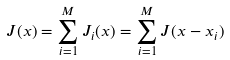Convert formula to latex. <formula><loc_0><loc_0><loc_500><loc_500>J ( { x } ) = \sum _ { i = 1 } ^ { M } J _ { i } ( { x } ) = \sum _ { i = 1 } ^ { M } J ( { x } - { x _ { i } } )</formula> 